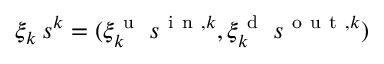<formula> <loc_0><loc_0><loc_500><loc_500>\xi _ { k } \, s ^ { k } = ( \xi _ { k } ^ { u } \, s ^ { i n , k } , \xi _ { k } ^ { d } \, s ^ { o u t , k } )</formula> 